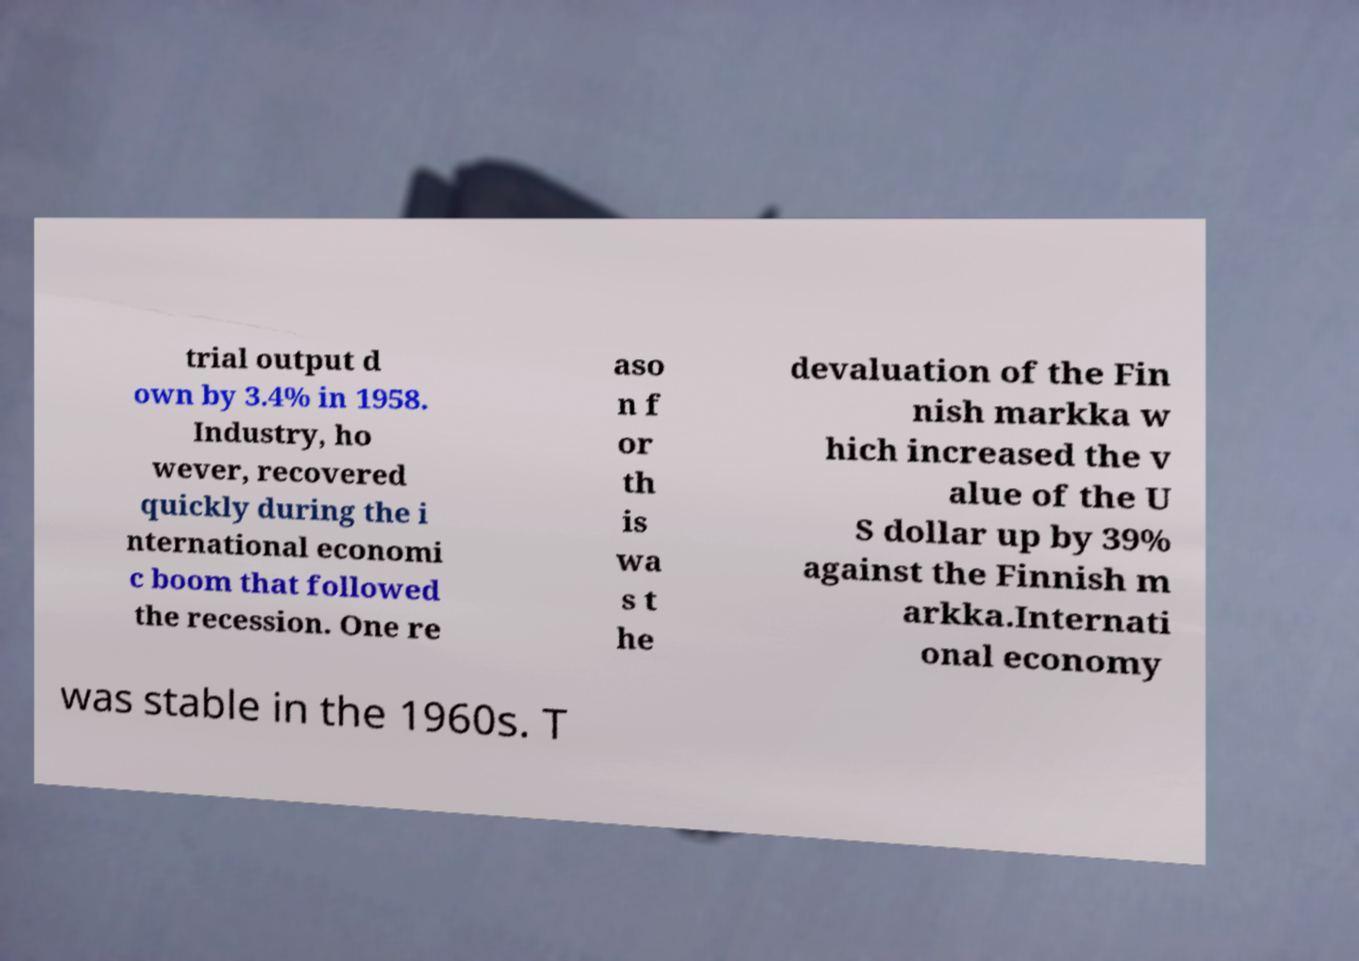Could you extract and type out the text from this image? trial output d own by 3.4% in 1958. Industry, ho wever, recovered quickly during the i nternational economi c boom that followed the recession. One re aso n f or th is wa s t he devaluation of the Fin nish markka w hich increased the v alue of the U S dollar up by 39% against the Finnish m arkka.Internati onal economy was stable in the 1960s. T 